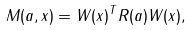<formula> <loc_0><loc_0><loc_500><loc_500>M ( a , x ) = W ( x ) ^ { T } R ( a ) W ( x ) ,</formula> 